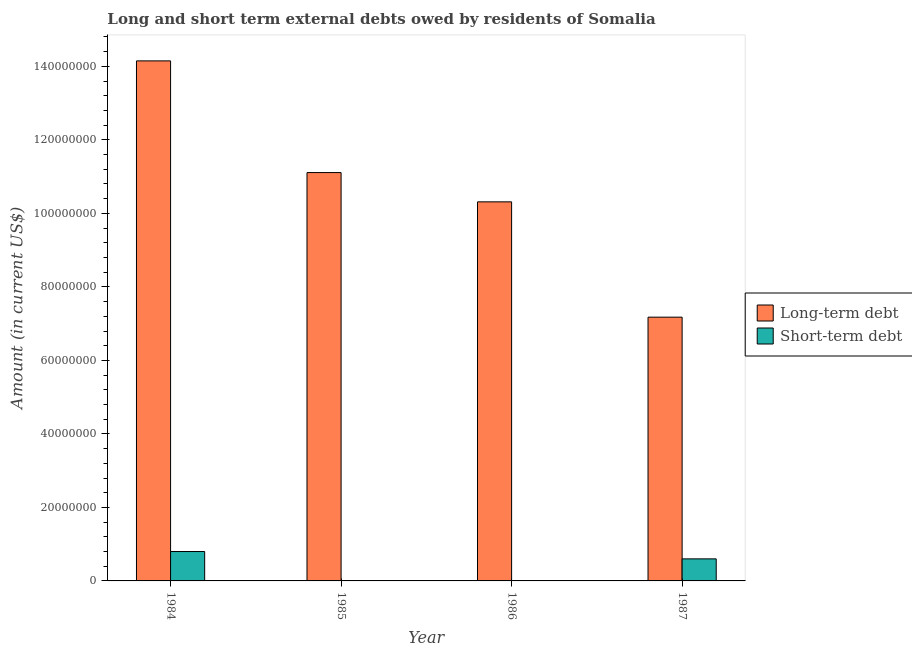How many bars are there on the 3rd tick from the left?
Your response must be concise. 1. How many bars are there on the 3rd tick from the right?
Make the answer very short. 1. In how many cases, is the number of bars for a given year not equal to the number of legend labels?
Ensure brevity in your answer.  2. What is the long-term debts owed by residents in 1986?
Your answer should be very brief. 1.03e+08. Across all years, what is the maximum long-term debts owed by residents?
Provide a short and direct response. 1.42e+08. Across all years, what is the minimum long-term debts owed by residents?
Make the answer very short. 7.18e+07. In which year was the short-term debts owed by residents maximum?
Your answer should be compact. 1984. What is the total long-term debts owed by residents in the graph?
Make the answer very short. 4.28e+08. What is the difference between the long-term debts owed by residents in 1986 and that in 1987?
Offer a terse response. 3.14e+07. What is the difference between the short-term debts owed by residents in 1984 and the long-term debts owed by residents in 1986?
Offer a very short reply. 8.00e+06. What is the average short-term debts owed by residents per year?
Provide a succinct answer. 3.50e+06. What is the ratio of the long-term debts owed by residents in 1985 to that in 1987?
Your response must be concise. 1.55. Is the difference between the long-term debts owed by residents in 1986 and 1987 greater than the difference between the short-term debts owed by residents in 1986 and 1987?
Your response must be concise. No. What is the difference between the highest and the second highest long-term debts owed by residents?
Your answer should be very brief. 3.04e+07. What is the difference between the highest and the lowest short-term debts owed by residents?
Make the answer very short. 8.00e+06. How many bars are there?
Your answer should be very brief. 6. Are all the bars in the graph horizontal?
Ensure brevity in your answer.  No. How many years are there in the graph?
Make the answer very short. 4. Does the graph contain any zero values?
Your answer should be compact. Yes. Does the graph contain grids?
Offer a terse response. No. How are the legend labels stacked?
Your answer should be compact. Vertical. What is the title of the graph?
Your answer should be compact. Long and short term external debts owed by residents of Somalia. Does "Passenger Transport Items" appear as one of the legend labels in the graph?
Make the answer very short. No. What is the label or title of the X-axis?
Ensure brevity in your answer.  Year. What is the label or title of the Y-axis?
Your answer should be very brief. Amount (in current US$). What is the Amount (in current US$) in Long-term debt in 1984?
Your answer should be very brief. 1.42e+08. What is the Amount (in current US$) of Long-term debt in 1985?
Offer a very short reply. 1.11e+08. What is the Amount (in current US$) of Long-term debt in 1986?
Give a very brief answer. 1.03e+08. What is the Amount (in current US$) in Long-term debt in 1987?
Provide a succinct answer. 7.18e+07. Across all years, what is the maximum Amount (in current US$) in Long-term debt?
Keep it short and to the point. 1.42e+08. Across all years, what is the minimum Amount (in current US$) of Long-term debt?
Provide a succinct answer. 7.18e+07. Across all years, what is the minimum Amount (in current US$) of Short-term debt?
Offer a terse response. 0. What is the total Amount (in current US$) of Long-term debt in the graph?
Your answer should be compact. 4.28e+08. What is the total Amount (in current US$) of Short-term debt in the graph?
Make the answer very short. 1.40e+07. What is the difference between the Amount (in current US$) in Long-term debt in 1984 and that in 1985?
Make the answer very short. 3.04e+07. What is the difference between the Amount (in current US$) of Long-term debt in 1984 and that in 1986?
Your answer should be compact. 3.84e+07. What is the difference between the Amount (in current US$) of Long-term debt in 1984 and that in 1987?
Give a very brief answer. 6.97e+07. What is the difference between the Amount (in current US$) in Long-term debt in 1985 and that in 1986?
Give a very brief answer. 7.97e+06. What is the difference between the Amount (in current US$) of Long-term debt in 1985 and that in 1987?
Provide a short and direct response. 3.93e+07. What is the difference between the Amount (in current US$) of Long-term debt in 1986 and that in 1987?
Offer a very short reply. 3.14e+07. What is the difference between the Amount (in current US$) in Long-term debt in 1984 and the Amount (in current US$) in Short-term debt in 1987?
Your response must be concise. 1.36e+08. What is the difference between the Amount (in current US$) in Long-term debt in 1985 and the Amount (in current US$) in Short-term debt in 1987?
Your answer should be very brief. 1.05e+08. What is the difference between the Amount (in current US$) of Long-term debt in 1986 and the Amount (in current US$) of Short-term debt in 1987?
Offer a terse response. 9.71e+07. What is the average Amount (in current US$) of Long-term debt per year?
Keep it short and to the point. 1.07e+08. What is the average Amount (in current US$) in Short-term debt per year?
Offer a terse response. 3.50e+06. In the year 1984, what is the difference between the Amount (in current US$) in Long-term debt and Amount (in current US$) in Short-term debt?
Offer a very short reply. 1.34e+08. In the year 1987, what is the difference between the Amount (in current US$) of Long-term debt and Amount (in current US$) of Short-term debt?
Offer a very short reply. 6.58e+07. What is the ratio of the Amount (in current US$) in Long-term debt in 1984 to that in 1985?
Your answer should be compact. 1.27. What is the ratio of the Amount (in current US$) of Long-term debt in 1984 to that in 1986?
Give a very brief answer. 1.37. What is the ratio of the Amount (in current US$) in Long-term debt in 1984 to that in 1987?
Keep it short and to the point. 1.97. What is the ratio of the Amount (in current US$) of Long-term debt in 1985 to that in 1986?
Keep it short and to the point. 1.08. What is the ratio of the Amount (in current US$) in Long-term debt in 1985 to that in 1987?
Your response must be concise. 1.55. What is the ratio of the Amount (in current US$) in Long-term debt in 1986 to that in 1987?
Give a very brief answer. 1.44. What is the difference between the highest and the second highest Amount (in current US$) of Long-term debt?
Your answer should be compact. 3.04e+07. What is the difference between the highest and the lowest Amount (in current US$) of Long-term debt?
Your response must be concise. 6.97e+07. What is the difference between the highest and the lowest Amount (in current US$) in Short-term debt?
Ensure brevity in your answer.  8.00e+06. 